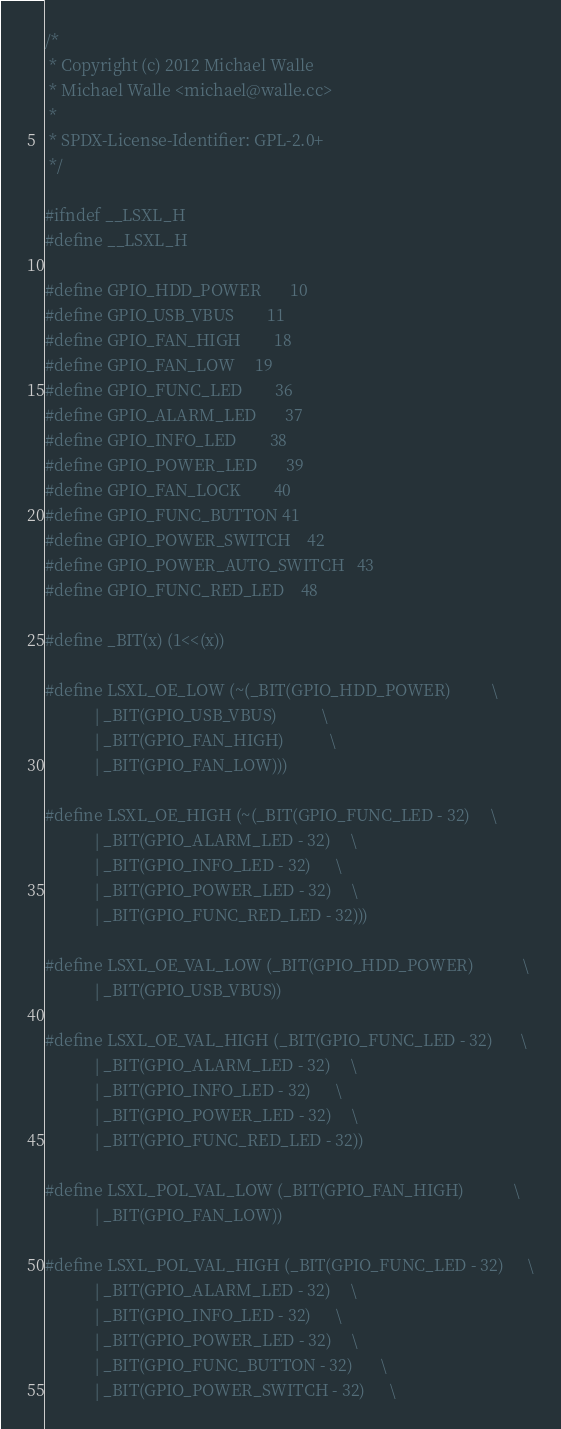<code> <loc_0><loc_0><loc_500><loc_500><_C_>/*
 * Copyright (c) 2012 Michael Walle
 * Michael Walle <michael@walle.cc>
 *
 * SPDX-License-Identifier:	GPL-2.0+
 */

#ifndef __LSXL_H
#define __LSXL_H

#define GPIO_HDD_POWER		10
#define GPIO_USB_VBUS		11
#define GPIO_FAN_HIGH		18
#define GPIO_FAN_LOW		19
#define GPIO_FUNC_LED		36
#define GPIO_ALARM_LED		37
#define GPIO_INFO_LED		38
#define GPIO_POWER_LED		39
#define GPIO_FAN_LOCK		40
#define GPIO_FUNC_BUTTON	41
#define GPIO_POWER_SWITCH	42
#define GPIO_POWER_AUTO_SWITCH	43
#define GPIO_FUNC_RED_LED	48

#define _BIT(x) (1<<(x))

#define LSXL_OE_LOW (~(_BIT(GPIO_HDD_POWER)		    \
			| _BIT(GPIO_USB_VBUS)		    \
			| _BIT(GPIO_FAN_HIGH)		    \
			| _BIT(GPIO_FAN_LOW)))

#define LSXL_OE_HIGH (~(_BIT(GPIO_FUNC_LED - 32)	    \
			| _BIT(GPIO_ALARM_LED - 32)	    \
			| _BIT(GPIO_INFO_LED - 32)	    \
			| _BIT(GPIO_POWER_LED - 32)	    \
			| _BIT(GPIO_FUNC_RED_LED - 32)))

#define LSXL_OE_VAL_LOW (_BIT(GPIO_HDD_POWER)		    \
			| _BIT(GPIO_USB_VBUS))

#define LSXL_OE_VAL_HIGH (_BIT(GPIO_FUNC_LED - 32)	    \
			| _BIT(GPIO_ALARM_LED - 32)	    \
			| _BIT(GPIO_INFO_LED - 32)	    \
			| _BIT(GPIO_POWER_LED - 32)	    \
			| _BIT(GPIO_FUNC_RED_LED - 32))

#define LSXL_POL_VAL_LOW (_BIT(GPIO_FAN_HIGH)		    \
			| _BIT(GPIO_FAN_LOW))

#define LSXL_POL_VAL_HIGH (_BIT(GPIO_FUNC_LED - 32)	    \
			| _BIT(GPIO_ALARM_LED - 32)	    \
			| _BIT(GPIO_INFO_LED - 32)	    \
			| _BIT(GPIO_POWER_LED - 32)	    \
			| _BIT(GPIO_FUNC_BUTTON - 32)	    \
			| _BIT(GPIO_POWER_SWITCH - 32)	    \</code> 